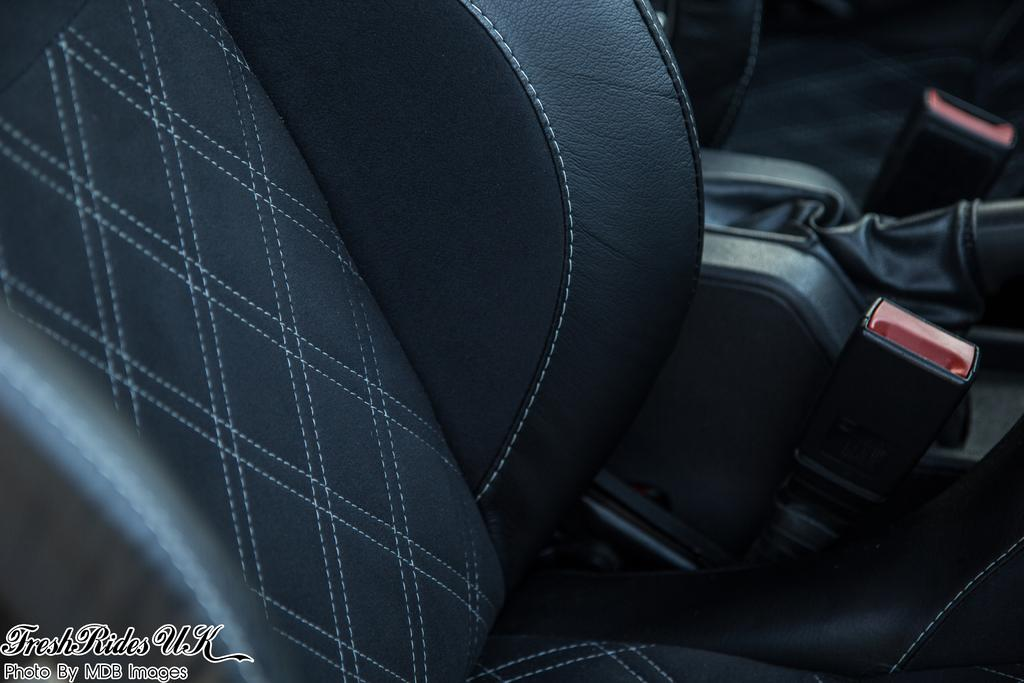What can be seen in the bottom left corner of the image? There is a watermark in the bottom left of the image. What is located in the background of the image? There is a seat in the background of the image. How would you describe the appearance of the background in the image? The background of the image is blurred. What type of nail is being used to hold the leather in place in the image? There is no nail or leather present in the image; the conversation focuses on the watermark, seat, and blurred background. 